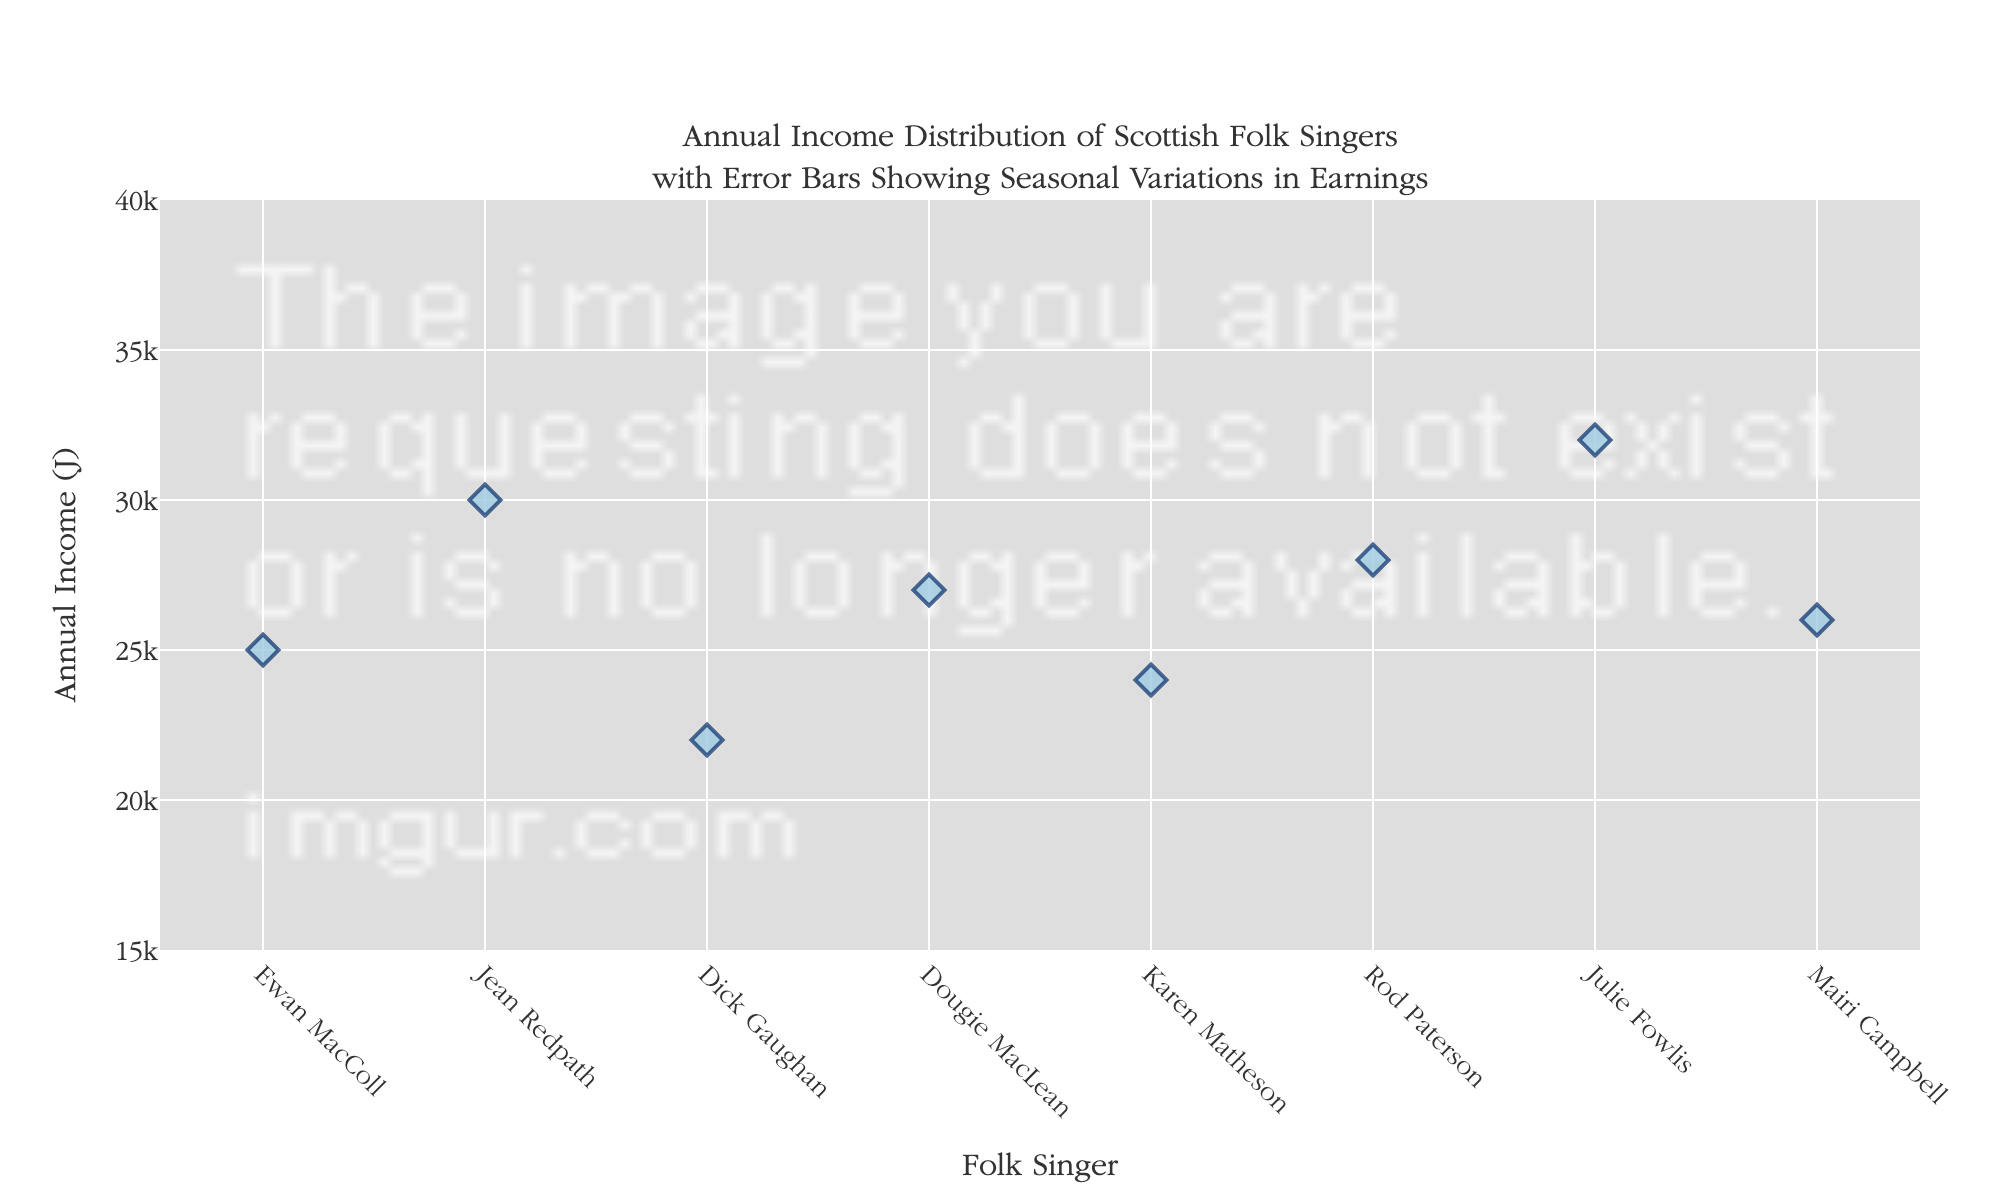Which folk singer has the highest annual income? Look for the marker that is the highest on the y-axis, which represents annual income.
Answer: Julie Fowlis What is the title of the plot? The title of the plot is shown at the top and usually includes a description of what the plot represents.
Answer: Annual Income Distribution of Scottish Folk Singers with Error Bars Showing Seasonal Variations in Earnings How many folk singers are presented in the plot? Count the number of markers or names on the x-axis.
Answer: 8 Which singer has the smallest difference between their winter and summer earnings? Compare the length of the error bars for each singer and identify the one with the shortest error bar from their winter to summer earnings.
Answer: Dick Gaughan What is the average annual income of all the singers combined? Add up all the annual incomes, then divide by the number of singers: (25000 + 30000 + 22000 + 27000 + 24000 + 28000 + 32000 + 26000) / 8 = £267500 / 8.
Answer: £26750 Which singer's income has the smallest range considering the seasonal variations? Analyze the length of the error bars for each singer; the smallest range will have the shortest total error bar length from winter to summer.
Answer: Ewan MacColl Which two singers have the closest annual income? Compare the annual incomes visually and find the pair with the smallest difference in their heights.
Answer: Mairi Campbell and Ewan MacColl By how much does Julie Fowlis’s summer earnings exceed her annual income? Subtract Julie Fowlis’s annual income from her summer earnings: 32000 - (32000 + 8500 - 32000) = 8500.
Answer: £5300 Which singer shows the greatest increase in income from winter to summer? Look for the singer with the longest positive error bar line from the bottom (winter) to the top (summer).
Answer: Julie Fowlis 